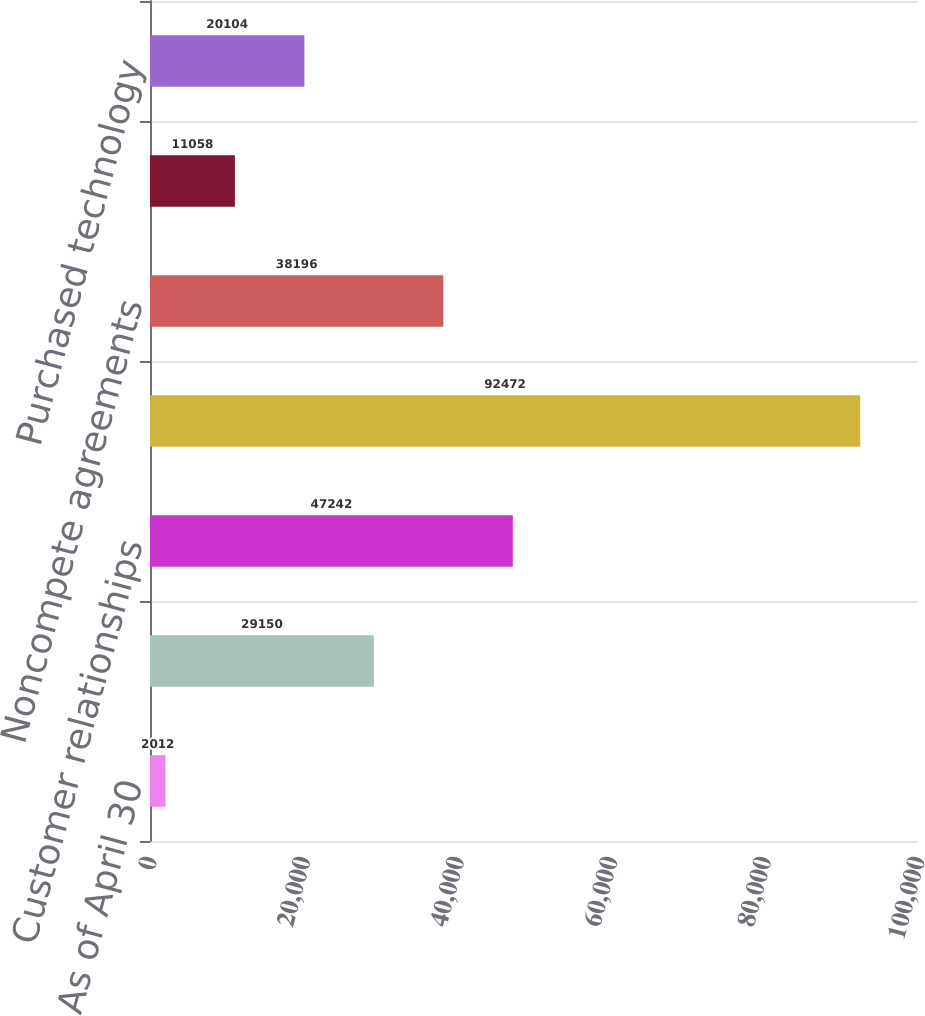Convert chart. <chart><loc_0><loc_0><loc_500><loc_500><bar_chart><fcel>As of April 30<fcel>Reacquired franchise rights<fcel>Customer relationships<fcel>Internally-developed software<fcel>Noncompete agreements<fcel>Franchise agreements<fcel>Purchased technology<nl><fcel>2012<fcel>29150<fcel>47242<fcel>92472<fcel>38196<fcel>11058<fcel>20104<nl></chart> 